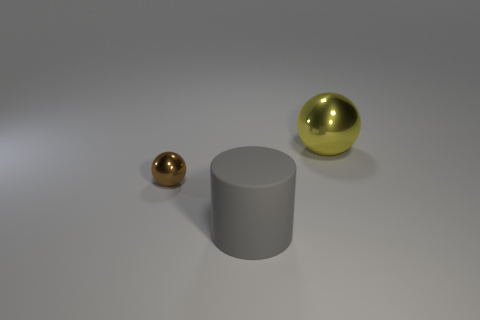What could these objects be used for if they were real? If these objects were real, their uses could vary based on their sizes and materials. The spheres could serve as decorative objects, perhaps as part of a modern art sculpture, while the cylinder might function as a base for a table or a standalone pedestal in an exhibition. Could the size of the objects tell us something about how far away they are? Absolutely. The relative sizes of the objects could be an indicator of their distance from the viewer if we assume they're positioned on the same surface. The smaller brown sphere could be further away from the camera, while the larger yellow sphere and the gray cylinder are closer. However, without additional contextual information, this is merely an assumption based on perspective cues. 